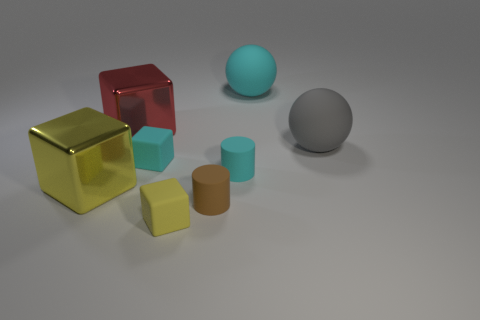Subtract all yellow metallic cubes. How many cubes are left? 3 Add 1 big yellow matte balls. How many objects exist? 9 Subtract all cyan cubes. How many cubes are left? 3 Add 2 large gray rubber objects. How many large gray rubber objects are left? 3 Add 5 large blue metallic cubes. How many large blue metallic cubes exist? 5 Subtract 0 purple cylinders. How many objects are left? 8 Subtract all cylinders. How many objects are left? 6 Subtract all gray blocks. Subtract all gray spheres. How many blocks are left? 4 Subtract all purple blocks. How many yellow cylinders are left? 0 Subtract all purple metal blocks. Subtract all big yellow objects. How many objects are left? 7 